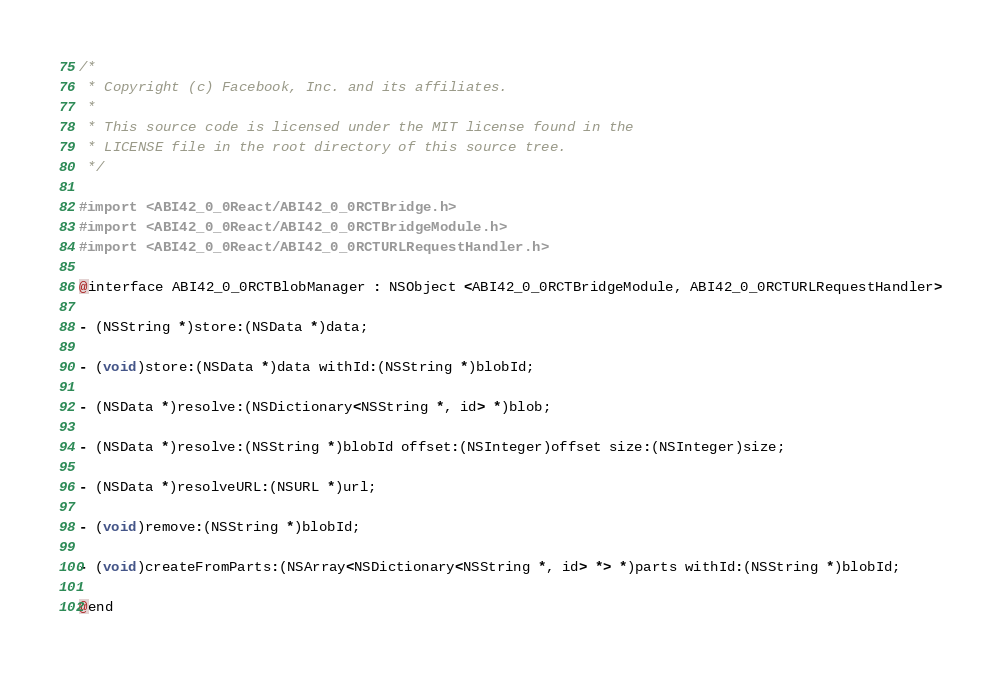Convert code to text. <code><loc_0><loc_0><loc_500><loc_500><_C_>/*
 * Copyright (c) Facebook, Inc. and its affiliates.
 *
 * This source code is licensed under the MIT license found in the
 * LICENSE file in the root directory of this source tree.
 */

#import <ABI42_0_0React/ABI42_0_0RCTBridge.h>
#import <ABI42_0_0React/ABI42_0_0RCTBridgeModule.h>
#import <ABI42_0_0React/ABI42_0_0RCTURLRequestHandler.h>

@interface ABI42_0_0RCTBlobManager : NSObject <ABI42_0_0RCTBridgeModule, ABI42_0_0RCTURLRequestHandler>

- (NSString *)store:(NSData *)data;

- (void)store:(NSData *)data withId:(NSString *)blobId;

- (NSData *)resolve:(NSDictionary<NSString *, id> *)blob;

- (NSData *)resolve:(NSString *)blobId offset:(NSInteger)offset size:(NSInteger)size;

- (NSData *)resolveURL:(NSURL *)url;

- (void)remove:(NSString *)blobId;

- (void)createFromParts:(NSArray<NSDictionary<NSString *, id> *> *)parts withId:(NSString *)blobId;

@end
</code> 